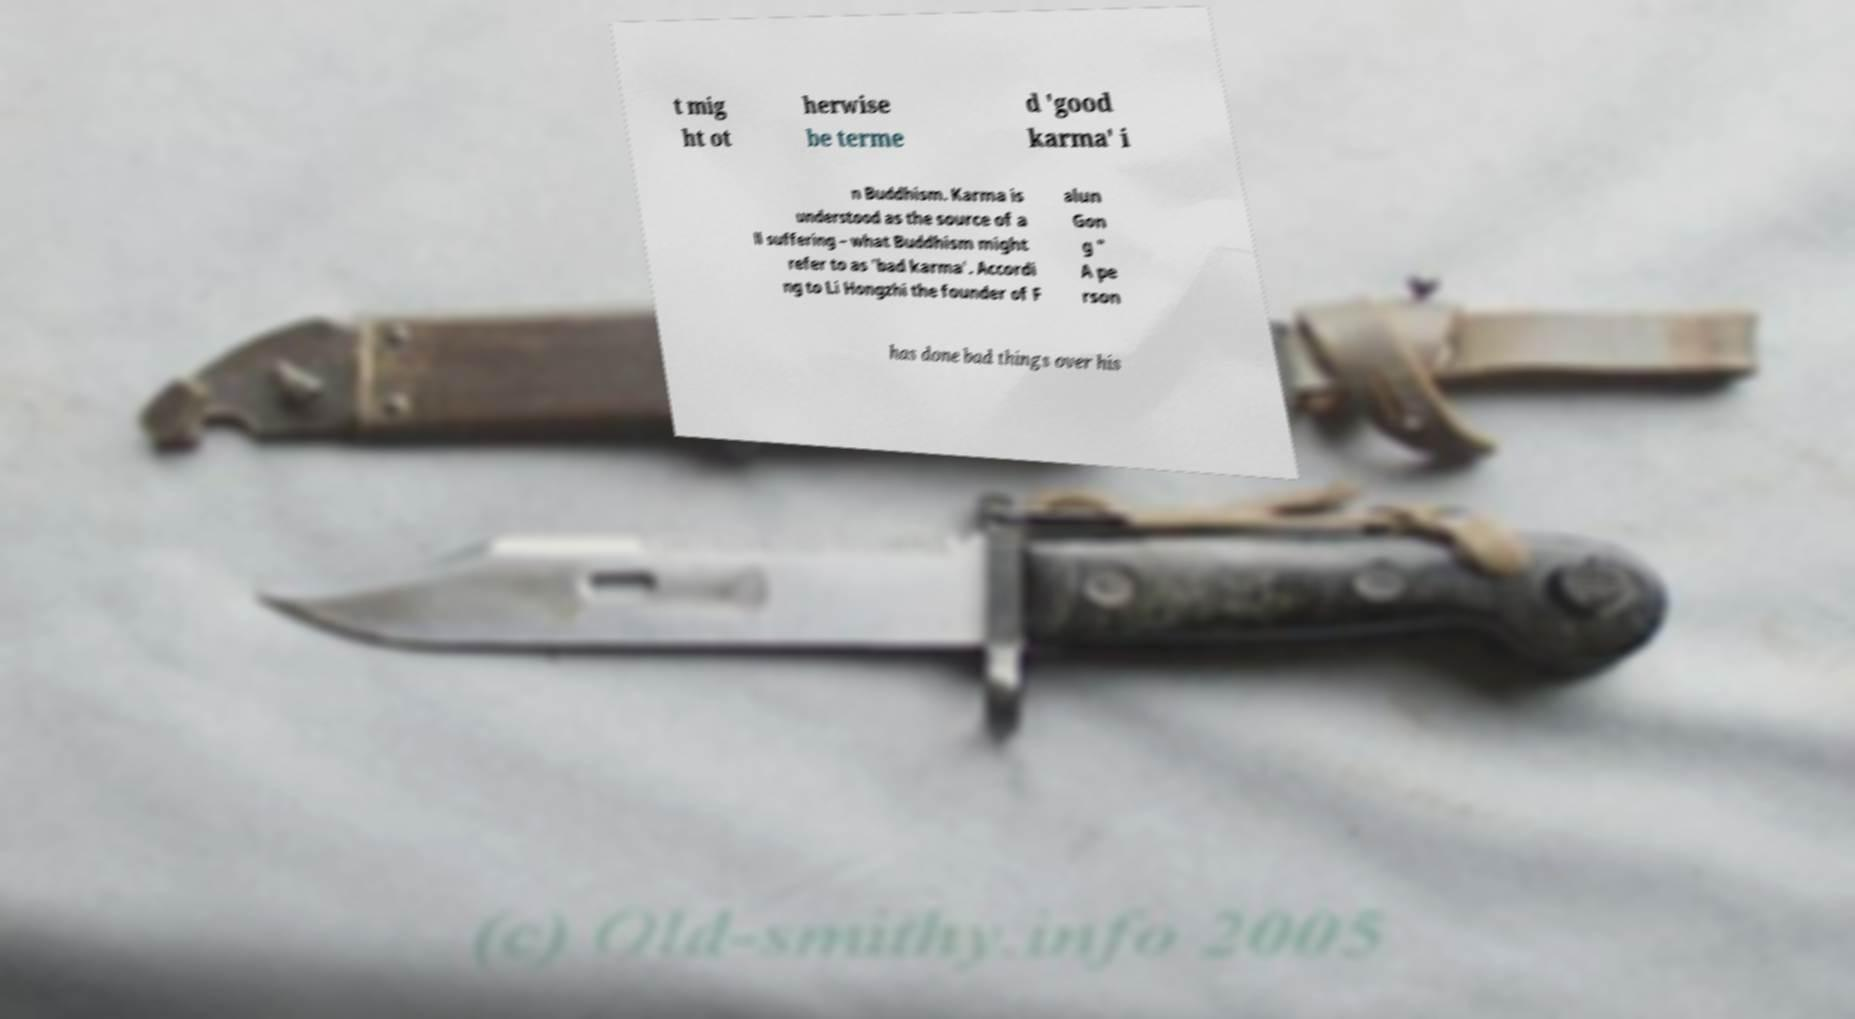I need the written content from this picture converted into text. Can you do that? t mig ht ot herwise be terme d 'good karma' i n Buddhism. Karma is understood as the source of a ll suffering – what Buddhism might refer to as 'bad karma'. Accordi ng to Li Hongzhi the founder of F alun Gon g " A pe rson has done bad things over his 